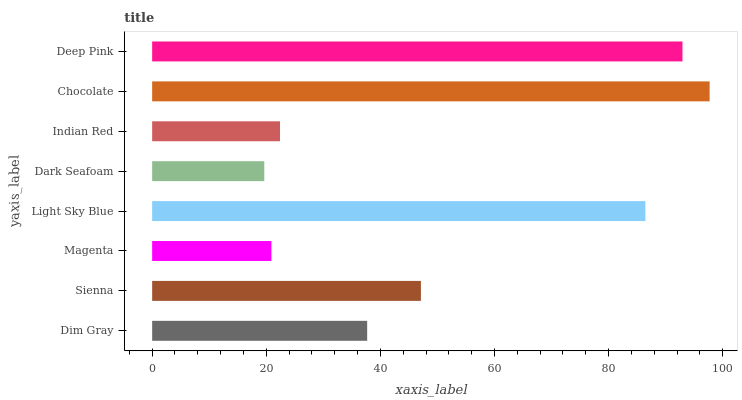Is Dark Seafoam the minimum?
Answer yes or no. Yes. Is Chocolate the maximum?
Answer yes or no. Yes. Is Sienna the minimum?
Answer yes or no. No. Is Sienna the maximum?
Answer yes or no. No. Is Sienna greater than Dim Gray?
Answer yes or no. Yes. Is Dim Gray less than Sienna?
Answer yes or no. Yes. Is Dim Gray greater than Sienna?
Answer yes or no. No. Is Sienna less than Dim Gray?
Answer yes or no. No. Is Sienna the high median?
Answer yes or no. Yes. Is Dim Gray the low median?
Answer yes or no. Yes. Is Indian Red the high median?
Answer yes or no. No. Is Sienna the low median?
Answer yes or no. No. 